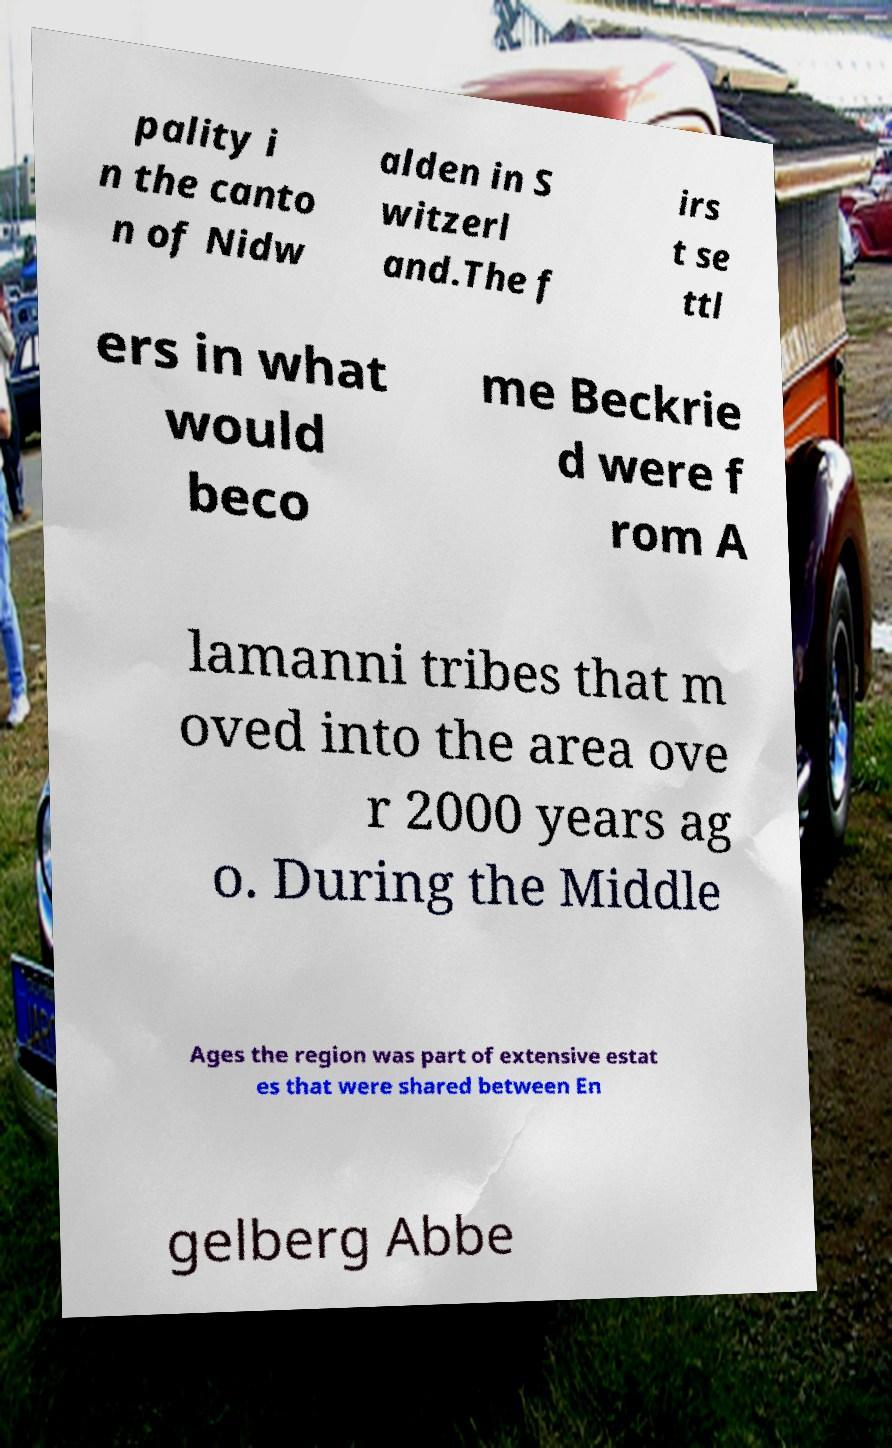Can you read and provide the text displayed in the image?This photo seems to have some interesting text. Can you extract and type it out for me? pality i n the canto n of Nidw alden in S witzerl and.The f irs t se ttl ers in what would beco me Beckrie d were f rom A lamanni tribes that m oved into the area ove r 2000 years ag o. During the Middle Ages the region was part of extensive estat es that were shared between En gelberg Abbe 